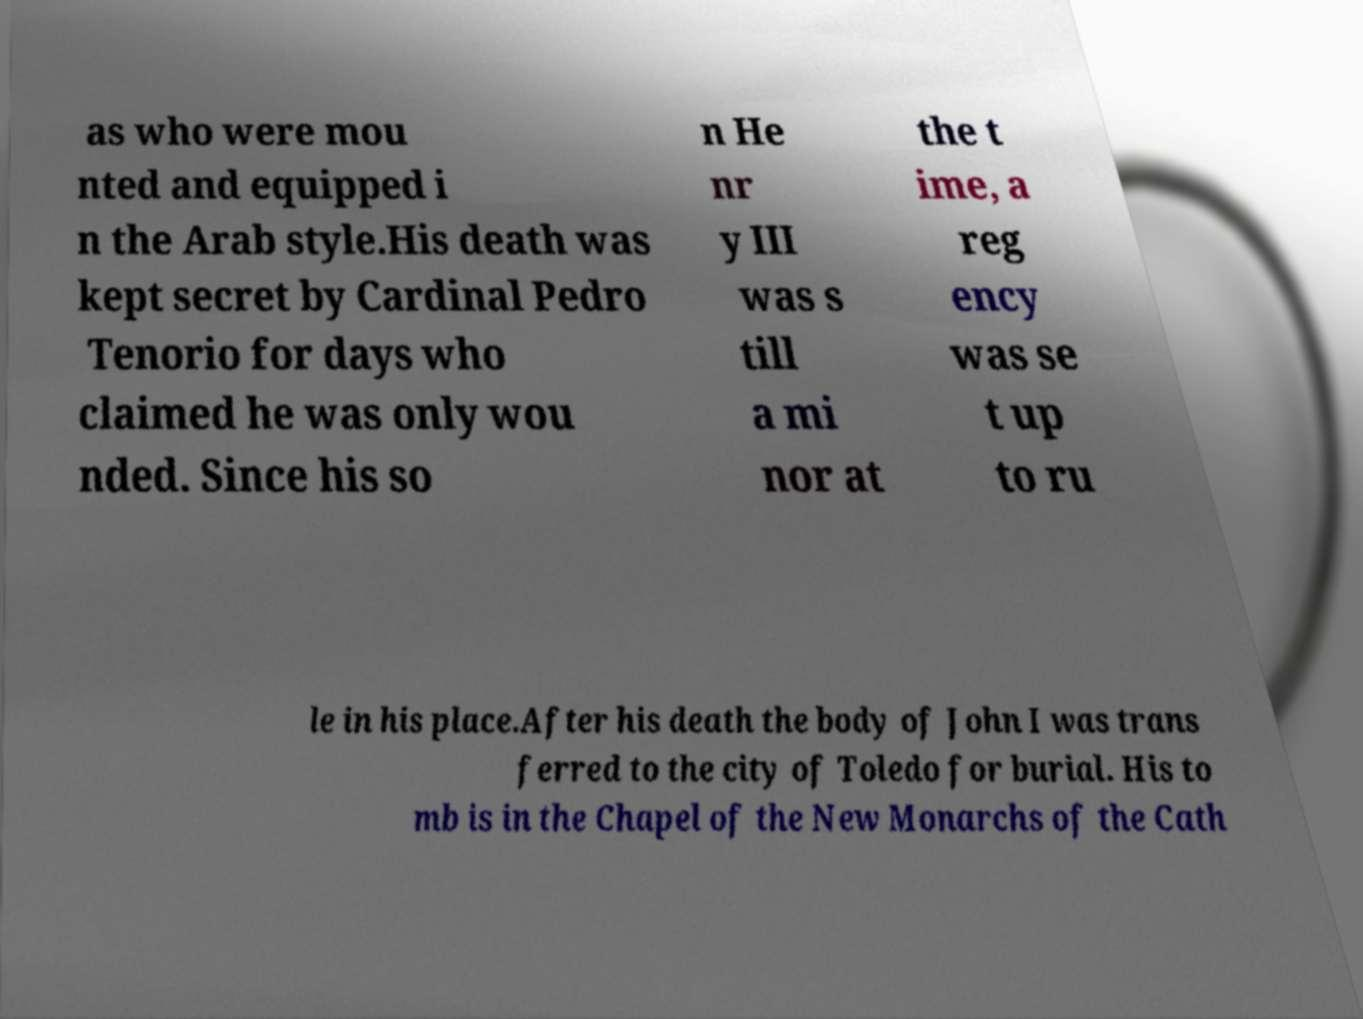Could you extract and type out the text from this image? as who were mou nted and equipped i n the Arab style.His death was kept secret by Cardinal Pedro Tenorio for days who claimed he was only wou nded. Since his so n He nr y III was s till a mi nor at the t ime, a reg ency was se t up to ru le in his place.After his death the body of John I was trans ferred to the city of Toledo for burial. His to mb is in the Chapel of the New Monarchs of the Cath 